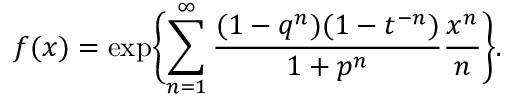Convert formula to latex. <formula><loc_0><loc_0><loc_500><loc_500>f ( x ) = \exp \left \{ \sum _ { n = 1 } ^ { \infty } { \frac { ( 1 - q ^ { n } ) ( 1 - t ^ { - n } ) } { 1 + p ^ { n } } } { \frac { x ^ { n } } { n } } \right \} .</formula> 